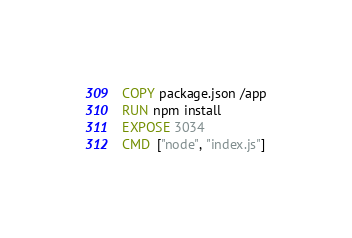<code> <loc_0><loc_0><loc_500><loc_500><_Dockerfile_>COPY package.json /app
RUN npm install
EXPOSE 3034
CMD  ["node", "index.js"]</code> 